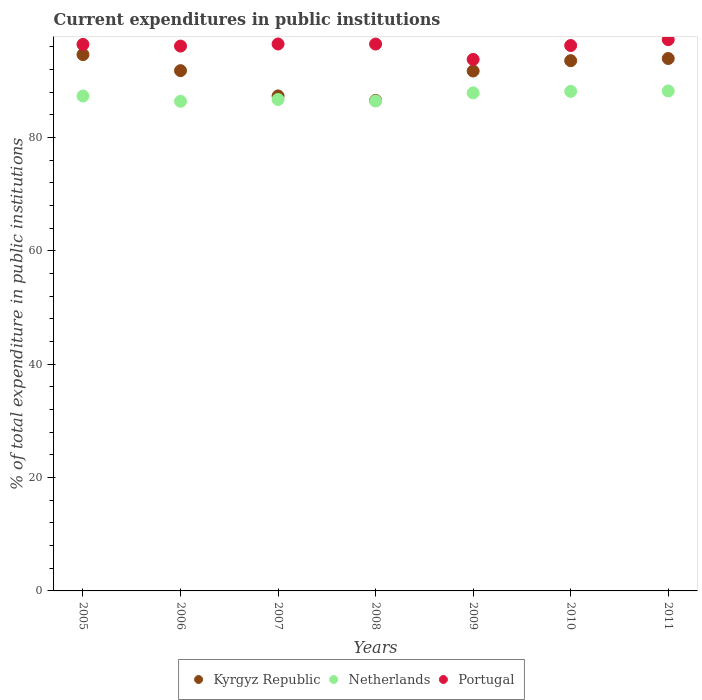What is the current expenditures in public institutions in Portugal in 2010?
Provide a succinct answer. 96.21. Across all years, what is the maximum current expenditures in public institutions in Portugal?
Your response must be concise. 97.24. Across all years, what is the minimum current expenditures in public institutions in Kyrgyz Republic?
Offer a very short reply. 86.53. In which year was the current expenditures in public institutions in Kyrgyz Republic minimum?
Ensure brevity in your answer.  2008. What is the total current expenditures in public institutions in Portugal in the graph?
Offer a terse response. 672.66. What is the difference between the current expenditures in public institutions in Portugal in 2008 and that in 2009?
Your answer should be compact. 2.71. What is the difference between the current expenditures in public institutions in Netherlands in 2006 and the current expenditures in public institutions in Portugal in 2010?
Provide a short and direct response. -9.84. What is the average current expenditures in public institutions in Netherlands per year?
Your answer should be very brief. 87.28. In the year 2007, what is the difference between the current expenditures in public institutions in Netherlands and current expenditures in public institutions in Kyrgyz Republic?
Provide a succinct answer. -0.63. What is the ratio of the current expenditures in public institutions in Portugal in 2007 to that in 2010?
Keep it short and to the point. 1. Is the difference between the current expenditures in public institutions in Netherlands in 2006 and 2009 greater than the difference between the current expenditures in public institutions in Kyrgyz Republic in 2006 and 2009?
Keep it short and to the point. No. What is the difference between the highest and the second highest current expenditures in public institutions in Portugal?
Give a very brief answer. 0.76. What is the difference between the highest and the lowest current expenditures in public institutions in Kyrgyz Republic?
Make the answer very short. 8.08. In how many years, is the current expenditures in public institutions in Kyrgyz Republic greater than the average current expenditures in public institutions in Kyrgyz Republic taken over all years?
Offer a terse response. 5. Is the sum of the current expenditures in public institutions in Portugal in 2007 and 2008 greater than the maximum current expenditures in public institutions in Netherlands across all years?
Provide a succinct answer. Yes. Is it the case that in every year, the sum of the current expenditures in public institutions in Portugal and current expenditures in public institutions in Netherlands  is greater than the current expenditures in public institutions in Kyrgyz Republic?
Your response must be concise. Yes. Is the current expenditures in public institutions in Kyrgyz Republic strictly less than the current expenditures in public institutions in Netherlands over the years?
Offer a terse response. No. How many years are there in the graph?
Provide a succinct answer. 7. What is the difference between two consecutive major ticks on the Y-axis?
Give a very brief answer. 20. Are the values on the major ticks of Y-axis written in scientific E-notation?
Provide a succinct answer. No. Does the graph contain any zero values?
Provide a short and direct response. No. What is the title of the graph?
Your answer should be very brief. Current expenditures in public institutions. What is the label or title of the X-axis?
Ensure brevity in your answer.  Years. What is the label or title of the Y-axis?
Keep it short and to the point. % of total expenditure in public institutions. What is the % of total expenditure in public institutions in Kyrgyz Republic in 2005?
Your answer should be compact. 94.61. What is the % of total expenditure in public institutions in Netherlands in 2005?
Give a very brief answer. 87.3. What is the % of total expenditure in public institutions of Portugal in 2005?
Your answer should be very brief. 96.4. What is the % of total expenditure in public institutions of Kyrgyz Republic in 2006?
Give a very brief answer. 91.77. What is the % of total expenditure in public institutions in Netherlands in 2006?
Offer a terse response. 86.37. What is the % of total expenditure in public institutions of Portugal in 2006?
Keep it short and to the point. 96.11. What is the % of total expenditure in public institutions of Kyrgyz Republic in 2007?
Ensure brevity in your answer.  87.32. What is the % of total expenditure in public institutions of Netherlands in 2007?
Ensure brevity in your answer.  86.69. What is the % of total expenditure in public institutions of Portugal in 2007?
Your answer should be compact. 96.48. What is the % of total expenditure in public institutions of Kyrgyz Republic in 2008?
Make the answer very short. 86.53. What is the % of total expenditure in public institutions in Netherlands in 2008?
Provide a short and direct response. 86.43. What is the % of total expenditure in public institutions of Portugal in 2008?
Keep it short and to the point. 96.47. What is the % of total expenditure in public institutions of Kyrgyz Republic in 2009?
Offer a very short reply. 91.71. What is the % of total expenditure in public institutions in Netherlands in 2009?
Provide a succinct answer. 87.85. What is the % of total expenditure in public institutions of Portugal in 2009?
Provide a short and direct response. 93.76. What is the % of total expenditure in public institutions of Kyrgyz Republic in 2010?
Provide a succinct answer. 93.53. What is the % of total expenditure in public institutions of Netherlands in 2010?
Provide a short and direct response. 88.12. What is the % of total expenditure in public institutions in Portugal in 2010?
Keep it short and to the point. 96.21. What is the % of total expenditure in public institutions of Kyrgyz Republic in 2011?
Make the answer very short. 93.92. What is the % of total expenditure in public institutions in Netherlands in 2011?
Make the answer very short. 88.19. What is the % of total expenditure in public institutions in Portugal in 2011?
Provide a succinct answer. 97.24. Across all years, what is the maximum % of total expenditure in public institutions of Kyrgyz Republic?
Keep it short and to the point. 94.61. Across all years, what is the maximum % of total expenditure in public institutions of Netherlands?
Make the answer very short. 88.19. Across all years, what is the maximum % of total expenditure in public institutions of Portugal?
Ensure brevity in your answer.  97.24. Across all years, what is the minimum % of total expenditure in public institutions in Kyrgyz Republic?
Provide a short and direct response. 86.53. Across all years, what is the minimum % of total expenditure in public institutions in Netherlands?
Provide a short and direct response. 86.37. Across all years, what is the minimum % of total expenditure in public institutions of Portugal?
Keep it short and to the point. 93.76. What is the total % of total expenditure in public institutions of Kyrgyz Republic in the graph?
Your response must be concise. 639.39. What is the total % of total expenditure in public institutions of Netherlands in the graph?
Your answer should be very brief. 610.95. What is the total % of total expenditure in public institutions in Portugal in the graph?
Your answer should be compact. 672.66. What is the difference between the % of total expenditure in public institutions in Kyrgyz Republic in 2005 and that in 2006?
Make the answer very short. 2.83. What is the difference between the % of total expenditure in public institutions of Netherlands in 2005 and that in 2006?
Offer a very short reply. 0.93. What is the difference between the % of total expenditure in public institutions of Portugal in 2005 and that in 2006?
Ensure brevity in your answer.  0.29. What is the difference between the % of total expenditure in public institutions of Kyrgyz Republic in 2005 and that in 2007?
Give a very brief answer. 7.29. What is the difference between the % of total expenditure in public institutions of Netherlands in 2005 and that in 2007?
Make the answer very short. 0.62. What is the difference between the % of total expenditure in public institutions in Portugal in 2005 and that in 2007?
Make the answer very short. -0.08. What is the difference between the % of total expenditure in public institutions of Kyrgyz Republic in 2005 and that in 2008?
Keep it short and to the point. 8.08. What is the difference between the % of total expenditure in public institutions in Netherlands in 2005 and that in 2008?
Provide a succinct answer. 0.87. What is the difference between the % of total expenditure in public institutions of Portugal in 2005 and that in 2008?
Keep it short and to the point. -0.07. What is the difference between the % of total expenditure in public institutions in Kyrgyz Republic in 2005 and that in 2009?
Offer a very short reply. 2.9. What is the difference between the % of total expenditure in public institutions of Netherlands in 2005 and that in 2009?
Offer a very short reply. -0.55. What is the difference between the % of total expenditure in public institutions of Portugal in 2005 and that in 2009?
Your answer should be very brief. 2.64. What is the difference between the % of total expenditure in public institutions of Kyrgyz Republic in 2005 and that in 2010?
Your response must be concise. 1.07. What is the difference between the % of total expenditure in public institutions in Netherlands in 2005 and that in 2010?
Offer a very short reply. -0.82. What is the difference between the % of total expenditure in public institutions of Portugal in 2005 and that in 2010?
Give a very brief answer. 0.19. What is the difference between the % of total expenditure in public institutions of Kyrgyz Republic in 2005 and that in 2011?
Provide a succinct answer. 0.69. What is the difference between the % of total expenditure in public institutions of Netherlands in 2005 and that in 2011?
Provide a succinct answer. -0.89. What is the difference between the % of total expenditure in public institutions of Portugal in 2005 and that in 2011?
Your answer should be compact. -0.84. What is the difference between the % of total expenditure in public institutions of Kyrgyz Republic in 2006 and that in 2007?
Your answer should be very brief. 4.46. What is the difference between the % of total expenditure in public institutions of Netherlands in 2006 and that in 2007?
Your answer should be compact. -0.32. What is the difference between the % of total expenditure in public institutions in Portugal in 2006 and that in 2007?
Make the answer very short. -0.37. What is the difference between the % of total expenditure in public institutions of Kyrgyz Republic in 2006 and that in 2008?
Offer a very short reply. 5.25. What is the difference between the % of total expenditure in public institutions in Netherlands in 2006 and that in 2008?
Offer a very short reply. -0.06. What is the difference between the % of total expenditure in public institutions in Portugal in 2006 and that in 2008?
Your answer should be compact. -0.36. What is the difference between the % of total expenditure in public institutions of Kyrgyz Republic in 2006 and that in 2009?
Your response must be concise. 0.06. What is the difference between the % of total expenditure in public institutions of Netherlands in 2006 and that in 2009?
Keep it short and to the point. -1.49. What is the difference between the % of total expenditure in public institutions in Portugal in 2006 and that in 2009?
Ensure brevity in your answer.  2.35. What is the difference between the % of total expenditure in public institutions of Kyrgyz Republic in 2006 and that in 2010?
Provide a short and direct response. -1.76. What is the difference between the % of total expenditure in public institutions in Netherlands in 2006 and that in 2010?
Make the answer very short. -1.75. What is the difference between the % of total expenditure in public institutions of Portugal in 2006 and that in 2010?
Offer a very short reply. -0.1. What is the difference between the % of total expenditure in public institutions of Kyrgyz Republic in 2006 and that in 2011?
Your answer should be compact. -2.14. What is the difference between the % of total expenditure in public institutions in Netherlands in 2006 and that in 2011?
Give a very brief answer. -1.82. What is the difference between the % of total expenditure in public institutions of Portugal in 2006 and that in 2011?
Provide a short and direct response. -1.13. What is the difference between the % of total expenditure in public institutions in Kyrgyz Republic in 2007 and that in 2008?
Offer a very short reply. 0.79. What is the difference between the % of total expenditure in public institutions in Netherlands in 2007 and that in 2008?
Provide a short and direct response. 0.26. What is the difference between the % of total expenditure in public institutions in Portugal in 2007 and that in 2008?
Keep it short and to the point. 0.01. What is the difference between the % of total expenditure in public institutions of Kyrgyz Republic in 2007 and that in 2009?
Give a very brief answer. -4.39. What is the difference between the % of total expenditure in public institutions in Netherlands in 2007 and that in 2009?
Provide a short and direct response. -1.17. What is the difference between the % of total expenditure in public institutions of Portugal in 2007 and that in 2009?
Your response must be concise. 2.72. What is the difference between the % of total expenditure in public institutions in Kyrgyz Republic in 2007 and that in 2010?
Provide a short and direct response. -6.22. What is the difference between the % of total expenditure in public institutions of Netherlands in 2007 and that in 2010?
Your answer should be very brief. -1.43. What is the difference between the % of total expenditure in public institutions of Portugal in 2007 and that in 2010?
Ensure brevity in your answer.  0.27. What is the difference between the % of total expenditure in public institutions of Kyrgyz Republic in 2007 and that in 2011?
Make the answer very short. -6.6. What is the difference between the % of total expenditure in public institutions of Netherlands in 2007 and that in 2011?
Offer a terse response. -1.5. What is the difference between the % of total expenditure in public institutions in Portugal in 2007 and that in 2011?
Provide a short and direct response. -0.76. What is the difference between the % of total expenditure in public institutions in Kyrgyz Republic in 2008 and that in 2009?
Offer a very short reply. -5.18. What is the difference between the % of total expenditure in public institutions of Netherlands in 2008 and that in 2009?
Offer a very short reply. -1.43. What is the difference between the % of total expenditure in public institutions of Portugal in 2008 and that in 2009?
Keep it short and to the point. 2.71. What is the difference between the % of total expenditure in public institutions in Kyrgyz Republic in 2008 and that in 2010?
Your answer should be compact. -7.01. What is the difference between the % of total expenditure in public institutions of Netherlands in 2008 and that in 2010?
Make the answer very short. -1.69. What is the difference between the % of total expenditure in public institutions of Portugal in 2008 and that in 2010?
Offer a terse response. 0.26. What is the difference between the % of total expenditure in public institutions in Kyrgyz Republic in 2008 and that in 2011?
Give a very brief answer. -7.39. What is the difference between the % of total expenditure in public institutions of Netherlands in 2008 and that in 2011?
Your answer should be very brief. -1.76. What is the difference between the % of total expenditure in public institutions of Portugal in 2008 and that in 2011?
Offer a terse response. -0.78. What is the difference between the % of total expenditure in public institutions of Kyrgyz Republic in 2009 and that in 2010?
Give a very brief answer. -1.82. What is the difference between the % of total expenditure in public institutions in Netherlands in 2009 and that in 2010?
Keep it short and to the point. -0.27. What is the difference between the % of total expenditure in public institutions of Portugal in 2009 and that in 2010?
Make the answer very short. -2.45. What is the difference between the % of total expenditure in public institutions in Kyrgyz Republic in 2009 and that in 2011?
Your answer should be very brief. -2.2. What is the difference between the % of total expenditure in public institutions of Netherlands in 2009 and that in 2011?
Provide a succinct answer. -0.33. What is the difference between the % of total expenditure in public institutions in Portugal in 2009 and that in 2011?
Your answer should be very brief. -3.49. What is the difference between the % of total expenditure in public institutions of Kyrgyz Republic in 2010 and that in 2011?
Your answer should be very brief. -0.38. What is the difference between the % of total expenditure in public institutions in Netherlands in 2010 and that in 2011?
Provide a short and direct response. -0.07. What is the difference between the % of total expenditure in public institutions of Portugal in 2010 and that in 2011?
Your response must be concise. -1.03. What is the difference between the % of total expenditure in public institutions in Kyrgyz Republic in 2005 and the % of total expenditure in public institutions in Netherlands in 2006?
Your answer should be compact. 8.24. What is the difference between the % of total expenditure in public institutions in Kyrgyz Republic in 2005 and the % of total expenditure in public institutions in Portugal in 2006?
Make the answer very short. -1.5. What is the difference between the % of total expenditure in public institutions in Netherlands in 2005 and the % of total expenditure in public institutions in Portugal in 2006?
Provide a short and direct response. -8.81. What is the difference between the % of total expenditure in public institutions in Kyrgyz Republic in 2005 and the % of total expenditure in public institutions in Netherlands in 2007?
Ensure brevity in your answer.  7.92. What is the difference between the % of total expenditure in public institutions in Kyrgyz Republic in 2005 and the % of total expenditure in public institutions in Portugal in 2007?
Ensure brevity in your answer.  -1.87. What is the difference between the % of total expenditure in public institutions of Netherlands in 2005 and the % of total expenditure in public institutions of Portugal in 2007?
Keep it short and to the point. -9.18. What is the difference between the % of total expenditure in public institutions in Kyrgyz Republic in 2005 and the % of total expenditure in public institutions in Netherlands in 2008?
Your answer should be very brief. 8.18. What is the difference between the % of total expenditure in public institutions of Kyrgyz Republic in 2005 and the % of total expenditure in public institutions of Portugal in 2008?
Ensure brevity in your answer.  -1.86. What is the difference between the % of total expenditure in public institutions in Netherlands in 2005 and the % of total expenditure in public institutions in Portugal in 2008?
Your answer should be compact. -9.17. What is the difference between the % of total expenditure in public institutions of Kyrgyz Republic in 2005 and the % of total expenditure in public institutions of Netherlands in 2009?
Make the answer very short. 6.75. What is the difference between the % of total expenditure in public institutions of Kyrgyz Republic in 2005 and the % of total expenditure in public institutions of Portugal in 2009?
Make the answer very short. 0.85. What is the difference between the % of total expenditure in public institutions in Netherlands in 2005 and the % of total expenditure in public institutions in Portugal in 2009?
Your response must be concise. -6.45. What is the difference between the % of total expenditure in public institutions of Kyrgyz Republic in 2005 and the % of total expenditure in public institutions of Netherlands in 2010?
Provide a short and direct response. 6.49. What is the difference between the % of total expenditure in public institutions of Kyrgyz Republic in 2005 and the % of total expenditure in public institutions of Portugal in 2010?
Keep it short and to the point. -1.6. What is the difference between the % of total expenditure in public institutions of Netherlands in 2005 and the % of total expenditure in public institutions of Portugal in 2010?
Offer a terse response. -8.91. What is the difference between the % of total expenditure in public institutions in Kyrgyz Republic in 2005 and the % of total expenditure in public institutions in Netherlands in 2011?
Offer a terse response. 6.42. What is the difference between the % of total expenditure in public institutions of Kyrgyz Republic in 2005 and the % of total expenditure in public institutions of Portugal in 2011?
Offer a terse response. -2.63. What is the difference between the % of total expenditure in public institutions in Netherlands in 2005 and the % of total expenditure in public institutions in Portugal in 2011?
Keep it short and to the point. -9.94. What is the difference between the % of total expenditure in public institutions in Kyrgyz Republic in 2006 and the % of total expenditure in public institutions in Netherlands in 2007?
Your response must be concise. 5.09. What is the difference between the % of total expenditure in public institutions in Kyrgyz Republic in 2006 and the % of total expenditure in public institutions in Portugal in 2007?
Offer a very short reply. -4.7. What is the difference between the % of total expenditure in public institutions in Netherlands in 2006 and the % of total expenditure in public institutions in Portugal in 2007?
Offer a very short reply. -10.11. What is the difference between the % of total expenditure in public institutions in Kyrgyz Republic in 2006 and the % of total expenditure in public institutions in Netherlands in 2008?
Make the answer very short. 5.35. What is the difference between the % of total expenditure in public institutions in Kyrgyz Republic in 2006 and the % of total expenditure in public institutions in Portugal in 2008?
Ensure brevity in your answer.  -4.69. What is the difference between the % of total expenditure in public institutions in Netherlands in 2006 and the % of total expenditure in public institutions in Portugal in 2008?
Offer a terse response. -10.1. What is the difference between the % of total expenditure in public institutions of Kyrgyz Republic in 2006 and the % of total expenditure in public institutions of Netherlands in 2009?
Make the answer very short. 3.92. What is the difference between the % of total expenditure in public institutions in Kyrgyz Republic in 2006 and the % of total expenditure in public institutions in Portugal in 2009?
Your answer should be very brief. -1.98. What is the difference between the % of total expenditure in public institutions in Netherlands in 2006 and the % of total expenditure in public institutions in Portugal in 2009?
Provide a short and direct response. -7.39. What is the difference between the % of total expenditure in public institutions of Kyrgyz Republic in 2006 and the % of total expenditure in public institutions of Netherlands in 2010?
Provide a short and direct response. 3.66. What is the difference between the % of total expenditure in public institutions of Kyrgyz Republic in 2006 and the % of total expenditure in public institutions of Portugal in 2010?
Your answer should be compact. -4.43. What is the difference between the % of total expenditure in public institutions of Netherlands in 2006 and the % of total expenditure in public institutions of Portugal in 2010?
Make the answer very short. -9.84. What is the difference between the % of total expenditure in public institutions in Kyrgyz Republic in 2006 and the % of total expenditure in public institutions in Netherlands in 2011?
Give a very brief answer. 3.59. What is the difference between the % of total expenditure in public institutions in Kyrgyz Republic in 2006 and the % of total expenditure in public institutions in Portugal in 2011?
Offer a terse response. -5.47. What is the difference between the % of total expenditure in public institutions in Netherlands in 2006 and the % of total expenditure in public institutions in Portugal in 2011?
Your answer should be very brief. -10.87. What is the difference between the % of total expenditure in public institutions of Kyrgyz Republic in 2007 and the % of total expenditure in public institutions of Netherlands in 2008?
Give a very brief answer. 0.89. What is the difference between the % of total expenditure in public institutions in Kyrgyz Republic in 2007 and the % of total expenditure in public institutions in Portugal in 2008?
Offer a very short reply. -9.15. What is the difference between the % of total expenditure in public institutions of Netherlands in 2007 and the % of total expenditure in public institutions of Portugal in 2008?
Provide a succinct answer. -9.78. What is the difference between the % of total expenditure in public institutions of Kyrgyz Republic in 2007 and the % of total expenditure in public institutions of Netherlands in 2009?
Provide a succinct answer. -0.54. What is the difference between the % of total expenditure in public institutions of Kyrgyz Republic in 2007 and the % of total expenditure in public institutions of Portugal in 2009?
Your response must be concise. -6.44. What is the difference between the % of total expenditure in public institutions of Netherlands in 2007 and the % of total expenditure in public institutions of Portugal in 2009?
Give a very brief answer. -7.07. What is the difference between the % of total expenditure in public institutions in Kyrgyz Republic in 2007 and the % of total expenditure in public institutions in Netherlands in 2010?
Provide a succinct answer. -0.8. What is the difference between the % of total expenditure in public institutions in Kyrgyz Republic in 2007 and the % of total expenditure in public institutions in Portugal in 2010?
Give a very brief answer. -8.89. What is the difference between the % of total expenditure in public institutions of Netherlands in 2007 and the % of total expenditure in public institutions of Portugal in 2010?
Offer a terse response. -9.52. What is the difference between the % of total expenditure in public institutions of Kyrgyz Republic in 2007 and the % of total expenditure in public institutions of Netherlands in 2011?
Your answer should be compact. -0.87. What is the difference between the % of total expenditure in public institutions in Kyrgyz Republic in 2007 and the % of total expenditure in public institutions in Portugal in 2011?
Your answer should be compact. -9.92. What is the difference between the % of total expenditure in public institutions in Netherlands in 2007 and the % of total expenditure in public institutions in Portugal in 2011?
Your answer should be very brief. -10.56. What is the difference between the % of total expenditure in public institutions in Kyrgyz Republic in 2008 and the % of total expenditure in public institutions in Netherlands in 2009?
Your answer should be compact. -1.33. What is the difference between the % of total expenditure in public institutions in Kyrgyz Republic in 2008 and the % of total expenditure in public institutions in Portugal in 2009?
Provide a short and direct response. -7.23. What is the difference between the % of total expenditure in public institutions in Netherlands in 2008 and the % of total expenditure in public institutions in Portugal in 2009?
Give a very brief answer. -7.33. What is the difference between the % of total expenditure in public institutions of Kyrgyz Republic in 2008 and the % of total expenditure in public institutions of Netherlands in 2010?
Offer a terse response. -1.59. What is the difference between the % of total expenditure in public institutions of Kyrgyz Republic in 2008 and the % of total expenditure in public institutions of Portugal in 2010?
Provide a short and direct response. -9.68. What is the difference between the % of total expenditure in public institutions of Netherlands in 2008 and the % of total expenditure in public institutions of Portugal in 2010?
Make the answer very short. -9.78. What is the difference between the % of total expenditure in public institutions of Kyrgyz Republic in 2008 and the % of total expenditure in public institutions of Netherlands in 2011?
Ensure brevity in your answer.  -1.66. What is the difference between the % of total expenditure in public institutions of Kyrgyz Republic in 2008 and the % of total expenditure in public institutions of Portugal in 2011?
Your answer should be very brief. -10.71. What is the difference between the % of total expenditure in public institutions in Netherlands in 2008 and the % of total expenditure in public institutions in Portugal in 2011?
Keep it short and to the point. -10.81. What is the difference between the % of total expenditure in public institutions of Kyrgyz Republic in 2009 and the % of total expenditure in public institutions of Netherlands in 2010?
Give a very brief answer. 3.59. What is the difference between the % of total expenditure in public institutions of Kyrgyz Republic in 2009 and the % of total expenditure in public institutions of Portugal in 2010?
Ensure brevity in your answer.  -4.5. What is the difference between the % of total expenditure in public institutions in Netherlands in 2009 and the % of total expenditure in public institutions in Portugal in 2010?
Make the answer very short. -8.35. What is the difference between the % of total expenditure in public institutions of Kyrgyz Republic in 2009 and the % of total expenditure in public institutions of Netherlands in 2011?
Your answer should be compact. 3.52. What is the difference between the % of total expenditure in public institutions of Kyrgyz Republic in 2009 and the % of total expenditure in public institutions of Portugal in 2011?
Provide a short and direct response. -5.53. What is the difference between the % of total expenditure in public institutions of Netherlands in 2009 and the % of total expenditure in public institutions of Portugal in 2011?
Provide a succinct answer. -9.39. What is the difference between the % of total expenditure in public institutions in Kyrgyz Republic in 2010 and the % of total expenditure in public institutions in Netherlands in 2011?
Give a very brief answer. 5.35. What is the difference between the % of total expenditure in public institutions of Kyrgyz Republic in 2010 and the % of total expenditure in public institutions of Portugal in 2011?
Keep it short and to the point. -3.71. What is the difference between the % of total expenditure in public institutions in Netherlands in 2010 and the % of total expenditure in public institutions in Portugal in 2011?
Your answer should be compact. -9.12. What is the average % of total expenditure in public institutions of Kyrgyz Republic per year?
Keep it short and to the point. 91.34. What is the average % of total expenditure in public institutions of Netherlands per year?
Ensure brevity in your answer.  87.28. What is the average % of total expenditure in public institutions in Portugal per year?
Offer a terse response. 96.09. In the year 2005, what is the difference between the % of total expenditure in public institutions of Kyrgyz Republic and % of total expenditure in public institutions of Netherlands?
Provide a succinct answer. 7.31. In the year 2005, what is the difference between the % of total expenditure in public institutions of Kyrgyz Republic and % of total expenditure in public institutions of Portugal?
Make the answer very short. -1.79. In the year 2005, what is the difference between the % of total expenditure in public institutions in Netherlands and % of total expenditure in public institutions in Portugal?
Keep it short and to the point. -9.1. In the year 2006, what is the difference between the % of total expenditure in public institutions of Kyrgyz Republic and % of total expenditure in public institutions of Netherlands?
Ensure brevity in your answer.  5.41. In the year 2006, what is the difference between the % of total expenditure in public institutions in Kyrgyz Republic and % of total expenditure in public institutions in Portugal?
Offer a very short reply. -4.33. In the year 2006, what is the difference between the % of total expenditure in public institutions of Netherlands and % of total expenditure in public institutions of Portugal?
Keep it short and to the point. -9.74. In the year 2007, what is the difference between the % of total expenditure in public institutions in Kyrgyz Republic and % of total expenditure in public institutions in Netherlands?
Offer a terse response. 0.63. In the year 2007, what is the difference between the % of total expenditure in public institutions in Kyrgyz Republic and % of total expenditure in public institutions in Portugal?
Keep it short and to the point. -9.16. In the year 2007, what is the difference between the % of total expenditure in public institutions in Netherlands and % of total expenditure in public institutions in Portugal?
Make the answer very short. -9.79. In the year 2008, what is the difference between the % of total expenditure in public institutions of Kyrgyz Republic and % of total expenditure in public institutions of Portugal?
Give a very brief answer. -9.94. In the year 2008, what is the difference between the % of total expenditure in public institutions in Netherlands and % of total expenditure in public institutions in Portugal?
Provide a succinct answer. -10.04. In the year 2009, what is the difference between the % of total expenditure in public institutions in Kyrgyz Republic and % of total expenditure in public institutions in Netherlands?
Offer a terse response. 3.86. In the year 2009, what is the difference between the % of total expenditure in public institutions of Kyrgyz Republic and % of total expenditure in public institutions of Portugal?
Your response must be concise. -2.04. In the year 2009, what is the difference between the % of total expenditure in public institutions in Netherlands and % of total expenditure in public institutions in Portugal?
Provide a short and direct response. -5.9. In the year 2010, what is the difference between the % of total expenditure in public institutions in Kyrgyz Republic and % of total expenditure in public institutions in Netherlands?
Your answer should be compact. 5.42. In the year 2010, what is the difference between the % of total expenditure in public institutions of Kyrgyz Republic and % of total expenditure in public institutions of Portugal?
Your answer should be very brief. -2.67. In the year 2010, what is the difference between the % of total expenditure in public institutions in Netherlands and % of total expenditure in public institutions in Portugal?
Offer a very short reply. -8.09. In the year 2011, what is the difference between the % of total expenditure in public institutions of Kyrgyz Republic and % of total expenditure in public institutions of Netherlands?
Offer a terse response. 5.73. In the year 2011, what is the difference between the % of total expenditure in public institutions of Kyrgyz Republic and % of total expenditure in public institutions of Portugal?
Give a very brief answer. -3.33. In the year 2011, what is the difference between the % of total expenditure in public institutions of Netherlands and % of total expenditure in public institutions of Portugal?
Provide a short and direct response. -9.05. What is the ratio of the % of total expenditure in public institutions in Kyrgyz Republic in 2005 to that in 2006?
Make the answer very short. 1.03. What is the ratio of the % of total expenditure in public institutions in Netherlands in 2005 to that in 2006?
Offer a very short reply. 1.01. What is the ratio of the % of total expenditure in public institutions of Kyrgyz Republic in 2005 to that in 2007?
Your answer should be compact. 1.08. What is the ratio of the % of total expenditure in public institutions of Netherlands in 2005 to that in 2007?
Give a very brief answer. 1.01. What is the ratio of the % of total expenditure in public institutions in Kyrgyz Republic in 2005 to that in 2008?
Ensure brevity in your answer.  1.09. What is the ratio of the % of total expenditure in public institutions in Kyrgyz Republic in 2005 to that in 2009?
Provide a short and direct response. 1.03. What is the ratio of the % of total expenditure in public institutions in Netherlands in 2005 to that in 2009?
Provide a succinct answer. 0.99. What is the ratio of the % of total expenditure in public institutions of Portugal in 2005 to that in 2009?
Ensure brevity in your answer.  1.03. What is the ratio of the % of total expenditure in public institutions in Kyrgyz Republic in 2005 to that in 2010?
Your response must be concise. 1.01. What is the ratio of the % of total expenditure in public institutions in Portugal in 2005 to that in 2010?
Provide a short and direct response. 1. What is the ratio of the % of total expenditure in public institutions of Kyrgyz Republic in 2005 to that in 2011?
Offer a very short reply. 1.01. What is the ratio of the % of total expenditure in public institutions in Netherlands in 2005 to that in 2011?
Your answer should be compact. 0.99. What is the ratio of the % of total expenditure in public institutions in Kyrgyz Republic in 2006 to that in 2007?
Your response must be concise. 1.05. What is the ratio of the % of total expenditure in public institutions of Kyrgyz Republic in 2006 to that in 2008?
Make the answer very short. 1.06. What is the ratio of the % of total expenditure in public institutions in Netherlands in 2006 to that in 2008?
Your response must be concise. 1. What is the ratio of the % of total expenditure in public institutions of Portugal in 2006 to that in 2008?
Give a very brief answer. 1. What is the ratio of the % of total expenditure in public institutions of Netherlands in 2006 to that in 2009?
Provide a short and direct response. 0.98. What is the ratio of the % of total expenditure in public institutions of Portugal in 2006 to that in 2009?
Make the answer very short. 1.03. What is the ratio of the % of total expenditure in public institutions in Kyrgyz Republic in 2006 to that in 2010?
Provide a short and direct response. 0.98. What is the ratio of the % of total expenditure in public institutions in Netherlands in 2006 to that in 2010?
Keep it short and to the point. 0.98. What is the ratio of the % of total expenditure in public institutions of Kyrgyz Republic in 2006 to that in 2011?
Give a very brief answer. 0.98. What is the ratio of the % of total expenditure in public institutions of Netherlands in 2006 to that in 2011?
Your answer should be compact. 0.98. What is the ratio of the % of total expenditure in public institutions of Portugal in 2006 to that in 2011?
Your answer should be very brief. 0.99. What is the ratio of the % of total expenditure in public institutions of Kyrgyz Republic in 2007 to that in 2008?
Offer a terse response. 1.01. What is the ratio of the % of total expenditure in public institutions in Netherlands in 2007 to that in 2008?
Offer a terse response. 1. What is the ratio of the % of total expenditure in public institutions in Portugal in 2007 to that in 2008?
Your answer should be compact. 1. What is the ratio of the % of total expenditure in public institutions in Kyrgyz Republic in 2007 to that in 2009?
Offer a very short reply. 0.95. What is the ratio of the % of total expenditure in public institutions of Netherlands in 2007 to that in 2009?
Your answer should be very brief. 0.99. What is the ratio of the % of total expenditure in public institutions of Kyrgyz Republic in 2007 to that in 2010?
Your answer should be compact. 0.93. What is the ratio of the % of total expenditure in public institutions of Netherlands in 2007 to that in 2010?
Offer a very short reply. 0.98. What is the ratio of the % of total expenditure in public institutions of Portugal in 2007 to that in 2010?
Keep it short and to the point. 1. What is the ratio of the % of total expenditure in public institutions of Kyrgyz Republic in 2007 to that in 2011?
Ensure brevity in your answer.  0.93. What is the ratio of the % of total expenditure in public institutions of Netherlands in 2007 to that in 2011?
Keep it short and to the point. 0.98. What is the ratio of the % of total expenditure in public institutions in Kyrgyz Republic in 2008 to that in 2009?
Offer a terse response. 0.94. What is the ratio of the % of total expenditure in public institutions of Netherlands in 2008 to that in 2009?
Offer a very short reply. 0.98. What is the ratio of the % of total expenditure in public institutions of Portugal in 2008 to that in 2009?
Offer a terse response. 1.03. What is the ratio of the % of total expenditure in public institutions of Kyrgyz Republic in 2008 to that in 2010?
Ensure brevity in your answer.  0.93. What is the ratio of the % of total expenditure in public institutions in Netherlands in 2008 to that in 2010?
Give a very brief answer. 0.98. What is the ratio of the % of total expenditure in public institutions of Portugal in 2008 to that in 2010?
Provide a short and direct response. 1. What is the ratio of the % of total expenditure in public institutions of Kyrgyz Republic in 2008 to that in 2011?
Ensure brevity in your answer.  0.92. What is the ratio of the % of total expenditure in public institutions in Netherlands in 2008 to that in 2011?
Provide a succinct answer. 0.98. What is the ratio of the % of total expenditure in public institutions of Kyrgyz Republic in 2009 to that in 2010?
Make the answer very short. 0.98. What is the ratio of the % of total expenditure in public institutions in Netherlands in 2009 to that in 2010?
Your response must be concise. 1. What is the ratio of the % of total expenditure in public institutions of Portugal in 2009 to that in 2010?
Keep it short and to the point. 0.97. What is the ratio of the % of total expenditure in public institutions of Kyrgyz Republic in 2009 to that in 2011?
Provide a succinct answer. 0.98. What is the ratio of the % of total expenditure in public institutions of Portugal in 2009 to that in 2011?
Provide a succinct answer. 0.96. What is the ratio of the % of total expenditure in public institutions in Kyrgyz Republic in 2010 to that in 2011?
Offer a very short reply. 1. What is the ratio of the % of total expenditure in public institutions of Netherlands in 2010 to that in 2011?
Ensure brevity in your answer.  1. What is the difference between the highest and the second highest % of total expenditure in public institutions of Kyrgyz Republic?
Your response must be concise. 0.69. What is the difference between the highest and the second highest % of total expenditure in public institutions of Netherlands?
Ensure brevity in your answer.  0.07. What is the difference between the highest and the second highest % of total expenditure in public institutions of Portugal?
Give a very brief answer. 0.76. What is the difference between the highest and the lowest % of total expenditure in public institutions in Kyrgyz Republic?
Provide a succinct answer. 8.08. What is the difference between the highest and the lowest % of total expenditure in public institutions in Netherlands?
Make the answer very short. 1.82. What is the difference between the highest and the lowest % of total expenditure in public institutions of Portugal?
Make the answer very short. 3.49. 